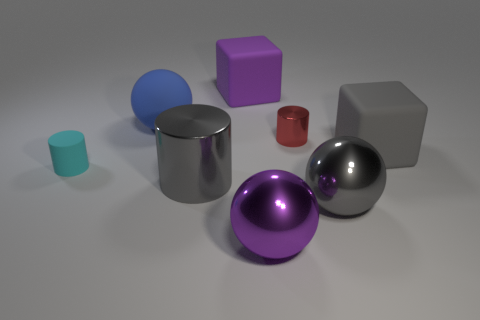What is the material of the big purple object that is behind the large sphere behind the small cyan matte cylinder?
Provide a short and direct response. Rubber. What material is the large gray thing that is on the right side of the large gray metallic cylinder and in front of the cyan rubber cylinder?
Offer a terse response. Metal. Is there a blue matte thing of the same shape as the tiny cyan rubber object?
Give a very brief answer. No. Is there a small matte cylinder that is left of the rubber block that is left of the gray rubber thing?
Provide a succinct answer. Yes. What number of cylinders are the same material as the tiny cyan thing?
Your response must be concise. 0. Is there a big object?
Offer a terse response. Yes. What number of matte cubes have the same color as the big cylinder?
Your answer should be compact. 1. Does the gray cylinder have the same material as the tiny cylinder that is behind the cyan thing?
Your response must be concise. Yes. Is the number of large gray matte things that are to the left of the big blue matte object greater than the number of rubber things?
Offer a terse response. No. Is there anything else that is the same size as the gray block?
Keep it short and to the point. Yes. 